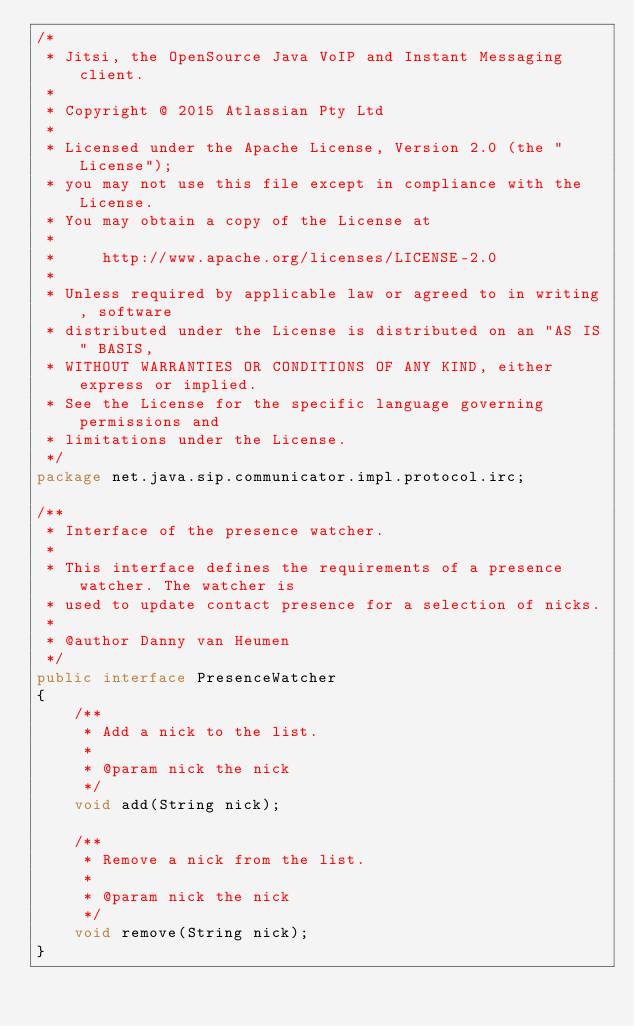Convert code to text. <code><loc_0><loc_0><loc_500><loc_500><_Java_>/*
 * Jitsi, the OpenSource Java VoIP and Instant Messaging client.
 *
 * Copyright @ 2015 Atlassian Pty Ltd
 *
 * Licensed under the Apache License, Version 2.0 (the "License");
 * you may not use this file except in compliance with the License.
 * You may obtain a copy of the License at
 *
 *     http://www.apache.org/licenses/LICENSE-2.0
 *
 * Unless required by applicable law or agreed to in writing, software
 * distributed under the License is distributed on an "AS IS" BASIS,
 * WITHOUT WARRANTIES OR CONDITIONS OF ANY KIND, either express or implied.
 * See the License for the specific language governing permissions and
 * limitations under the License.
 */
package net.java.sip.communicator.impl.protocol.irc;

/**
 * Interface of the presence watcher.
 * 
 * This interface defines the requirements of a presence watcher. The watcher is
 * used to update contact presence for a selection of nicks.
 * 
 * @author Danny van Heumen
 */
public interface PresenceWatcher
{
    /**
     * Add a nick to the list.
     *
     * @param nick the nick
     */
    void add(String nick);

    /**
     * Remove a nick from the list.
     *
     * @param nick the nick
     */
    void remove(String nick);
}
</code> 